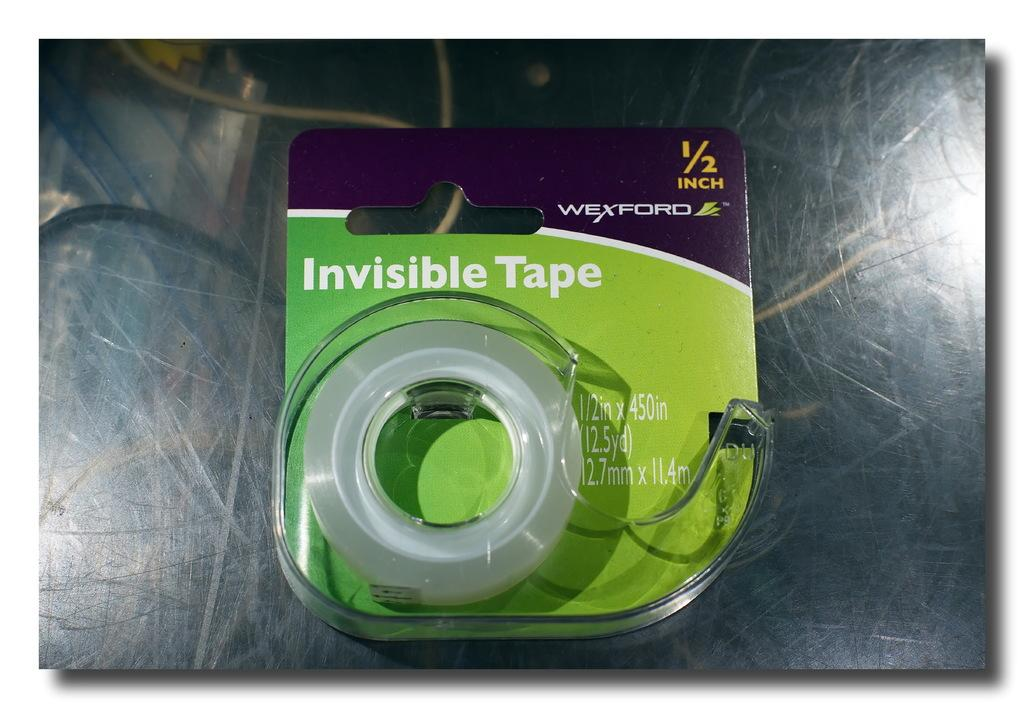What is present on the glass surface in the image? There is a card placed on a glass surface in the image. What is written or printed on the card? The card has text on it. What else can be seen in the image besides the card and glass surface? There is a tape and wires visible in the image. Can you tell if the image has been altered or modified in any way? Yes, the image has been edited. What type of shoe can be seen in the image? There is no shoe present in the image. How does the vest interact with the rain in the image? There is no vest or rain present in the image. 